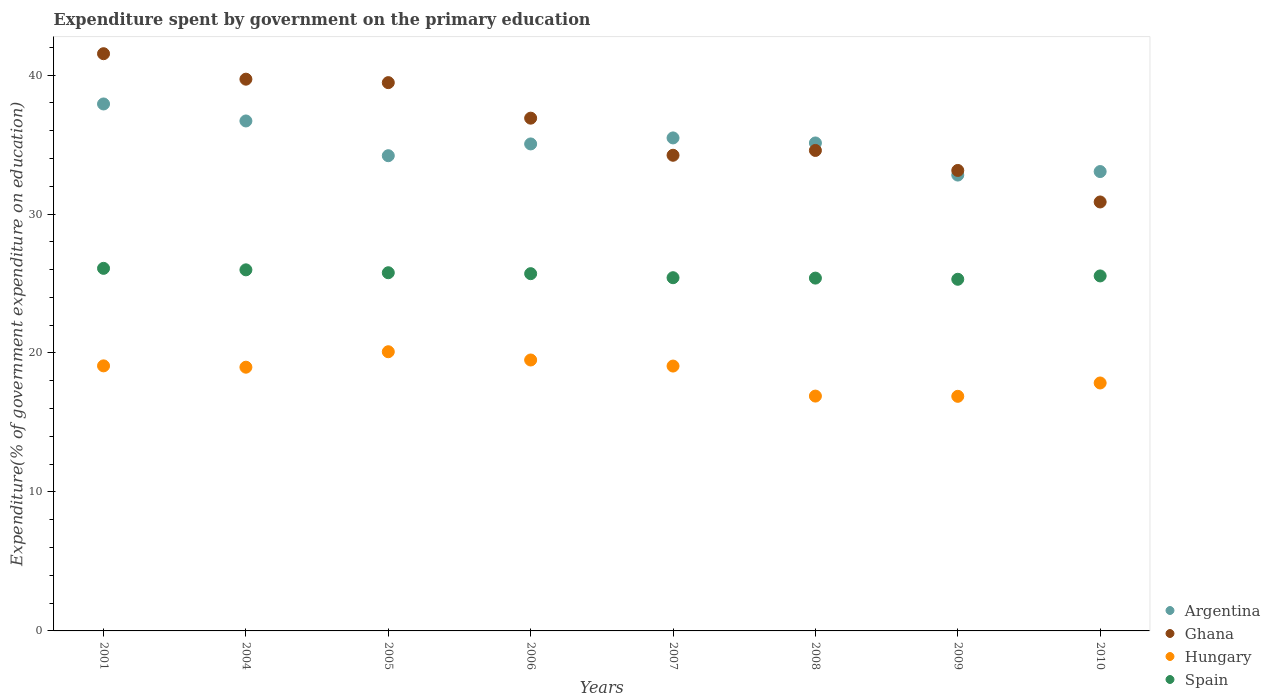How many different coloured dotlines are there?
Provide a short and direct response. 4. What is the expenditure spent by government on the primary education in Argentina in 2004?
Give a very brief answer. 36.7. Across all years, what is the maximum expenditure spent by government on the primary education in Hungary?
Give a very brief answer. 20.09. Across all years, what is the minimum expenditure spent by government on the primary education in Hungary?
Ensure brevity in your answer.  16.88. In which year was the expenditure spent by government on the primary education in Hungary maximum?
Ensure brevity in your answer.  2005. What is the total expenditure spent by government on the primary education in Hungary in the graph?
Give a very brief answer. 148.31. What is the difference between the expenditure spent by government on the primary education in Spain in 2004 and that in 2007?
Make the answer very short. 0.57. What is the difference between the expenditure spent by government on the primary education in Ghana in 2005 and the expenditure spent by government on the primary education in Hungary in 2010?
Make the answer very short. 21.61. What is the average expenditure spent by government on the primary education in Hungary per year?
Ensure brevity in your answer.  18.54. In the year 2005, what is the difference between the expenditure spent by government on the primary education in Hungary and expenditure spent by government on the primary education in Ghana?
Make the answer very short. -19.36. What is the ratio of the expenditure spent by government on the primary education in Hungary in 2001 to that in 2007?
Your answer should be very brief. 1. Is the difference between the expenditure spent by government on the primary education in Hungary in 2005 and 2007 greater than the difference between the expenditure spent by government on the primary education in Ghana in 2005 and 2007?
Your response must be concise. No. What is the difference between the highest and the second highest expenditure spent by government on the primary education in Ghana?
Your response must be concise. 1.83. What is the difference between the highest and the lowest expenditure spent by government on the primary education in Argentina?
Provide a succinct answer. 5.12. In how many years, is the expenditure spent by government on the primary education in Ghana greater than the average expenditure spent by government on the primary education in Ghana taken over all years?
Offer a very short reply. 4. Is the sum of the expenditure spent by government on the primary education in Argentina in 2004 and 2009 greater than the maximum expenditure spent by government on the primary education in Hungary across all years?
Your answer should be very brief. Yes. Is it the case that in every year, the sum of the expenditure spent by government on the primary education in Ghana and expenditure spent by government on the primary education in Spain  is greater than the expenditure spent by government on the primary education in Argentina?
Make the answer very short. Yes. Is the expenditure spent by government on the primary education in Ghana strictly greater than the expenditure spent by government on the primary education in Spain over the years?
Ensure brevity in your answer.  Yes. How many dotlines are there?
Offer a terse response. 4. How many years are there in the graph?
Give a very brief answer. 8. Does the graph contain any zero values?
Your answer should be compact. No. Where does the legend appear in the graph?
Make the answer very short. Bottom right. How many legend labels are there?
Offer a very short reply. 4. How are the legend labels stacked?
Your answer should be compact. Vertical. What is the title of the graph?
Ensure brevity in your answer.  Expenditure spent by government on the primary education. Does "Philippines" appear as one of the legend labels in the graph?
Give a very brief answer. No. What is the label or title of the Y-axis?
Provide a succinct answer. Expenditure(% of government expenditure on education). What is the Expenditure(% of government expenditure on education) of Argentina in 2001?
Ensure brevity in your answer.  37.92. What is the Expenditure(% of government expenditure on education) of Ghana in 2001?
Offer a very short reply. 41.54. What is the Expenditure(% of government expenditure on education) of Hungary in 2001?
Your answer should be compact. 19.07. What is the Expenditure(% of government expenditure on education) of Spain in 2001?
Give a very brief answer. 26.09. What is the Expenditure(% of government expenditure on education) of Argentina in 2004?
Your answer should be compact. 36.7. What is the Expenditure(% of government expenditure on education) in Ghana in 2004?
Provide a short and direct response. 39.7. What is the Expenditure(% of government expenditure on education) in Hungary in 2004?
Your response must be concise. 18.98. What is the Expenditure(% of government expenditure on education) of Spain in 2004?
Your response must be concise. 25.98. What is the Expenditure(% of government expenditure on education) of Argentina in 2005?
Ensure brevity in your answer.  34.2. What is the Expenditure(% of government expenditure on education) of Ghana in 2005?
Your answer should be very brief. 39.45. What is the Expenditure(% of government expenditure on education) in Hungary in 2005?
Offer a very short reply. 20.09. What is the Expenditure(% of government expenditure on education) of Spain in 2005?
Give a very brief answer. 25.77. What is the Expenditure(% of government expenditure on education) of Argentina in 2006?
Offer a terse response. 35.04. What is the Expenditure(% of government expenditure on education) of Ghana in 2006?
Ensure brevity in your answer.  36.9. What is the Expenditure(% of government expenditure on education) of Hungary in 2006?
Give a very brief answer. 19.5. What is the Expenditure(% of government expenditure on education) of Spain in 2006?
Make the answer very short. 25.71. What is the Expenditure(% of government expenditure on education) of Argentina in 2007?
Give a very brief answer. 35.48. What is the Expenditure(% of government expenditure on education) of Ghana in 2007?
Your answer should be compact. 34.23. What is the Expenditure(% of government expenditure on education) in Hungary in 2007?
Your answer should be very brief. 19.06. What is the Expenditure(% of government expenditure on education) in Spain in 2007?
Provide a short and direct response. 25.42. What is the Expenditure(% of government expenditure on education) of Argentina in 2008?
Your answer should be compact. 35.11. What is the Expenditure(% of government expenditure on education) in Ghana in 2008?
Keep it short and to the point. 34.57. What is the Expenditure(% of government expenditure on education) in Hungary in 2008?
Ensure brevity in your answer.  16.9. What is the Expenditure(% of government expenditure on education) in Spain in 2008?
Keep it short and to the point. 25.39. What is the Expenditure(% of government expenditure on education) of Argentina in 2009?
Your answer should be compact. 32.8. What is the Expenditure(% of government expenditure on education) of Ghana in 2009?
Your answer should be very brief. 33.13. What is the Expenditure(% of government expenditure on education) of Hungary in 2009?
Offer a very short reply. 16.88. What is the Expenditure(% of government expenditure on education) of Spain in 2009?
Make the answer very short. 25.3. What is the Expenditure(% of government expenditure on education) in Argentina in 2010?
Give a very brief answer. 33.05. What is the Expenditure(% of government expenditure on education) of Ghana in 2010?
Your answer should be compact. 30.87. What is the Expenditure(% of government expenditure on education) of Hungary in 2010?
Offer a very short reply. 17.84. What is the Expenditure(% of government expenditure on education) in Spain in 2010?
Provide a succinct answer. 25.54. Across all years, what is the maximum Expenditure(% of government expenditure on education) of Argentina?
Offer a very short reply. 37.92. Across all years, what is the maximum Expenditure(% of government expenditure on education) in Ghana?
Your answer should be compact. 41.54. Across all years, what is the maximum Expenditure(% of government expenditure on education) of Hungary?
Keep it short and to the point. 20.09. Across all years, what is the maximum Expenditure(% of government expenditure on education) of Spain?
Offer a very short reply. 26.09. Across all years, what is the minimum Expenditure(% of government expenditure on education) of Argentina?
Ensure brevity in your answer.  32.8. Across all years, what is the minimum Expenditure(% of government expenditure on education) of Ghana?
Make the answer very short. 30.87. Across all years, what is the minimum Expenditure(% of government expenditure on education) of Hungary?
Make the answer very short. 16.88. Across all years, what is the minimum Expenditure(% of government expenditure on education) of Spain?
Provide a short and direct response. 25.3. What is the total Expenditure(% of government expenditure on education) of Argentina in the graph?
Your answer should be compact. 280.3. What is the total Expenditure(% of government expenditure on education) of Ghana in the graph?
Provide a short and direct response. 290.39. What is the total Expenditure(% of government expenditure on education) of Hungary in the graph?
Offer a very short reply. 148.31. What is the total Expenditure(% of government expenditure on education) of Spain in the graph?
Your answer should be compact. 205.21. What is the difference between the Expenditure(% of government expenditure on education) in Argentina in 2001 and that in 2004?
Offer a very short reply. 1.22. What is the difference between the Expenditure(% of government expenditure on education) in Ghana in 2001 and that in 2004?
Provide a succinct answer. 1.83. What is the difference between the Expenditure(% of government expenditure on education) in Hungary in 2001 and that in 2004?
Give a very brief answer. 0.1. What is the difference between the Expenditure(% of government expenditure on education) of Spain in 2001 and that in 2004?
Provide a short and direct response. 0.11. What is the difference between the Expenditure(% of government expenditure on education) in Argentina in 2001 and that in 2005?
Your answer should be very brief. 3.72. What is the difference between the Expenditure(% of government expenditure on education) in Ghana in 2001 and that in 2005?
Your answer should be compact. 2.08. What is the difference between the Expenditure(% of government expenditure on education) of Hungary in 2001 and that in 2005?
Provide a succinct answer. -1.02. What is the difference between the Expenditure(% of government expenditure on education) of Spain in 2001 and that in 2005?
Your answer should be compact. 0.32. What is the difference between the Expenditure(% of government expenditure on education) of Argentina in 2001 and that in 2006?
Offer a terse response. 2.88. What is the difference between the Expenditure(% of government expenditure on education) in Ghana in 2001 and that in 2006?
Provide a short and direct response. 4.64. What is the difference between the Expenditure(% of government expenditure on education) of Hungary in 2001 and that in 2006?
Offer a terse response. -0.42. What is the difference between the Expenditure(% of government expenditure on education) in Spain in 2001 and that in 2006?
Provide a short and direct response. 0.38. What is the difference between the Expenditure(% of government expenditure on education) in Argentina in 2001 and that in 2007?
Your answer should be very brief. 2.44. What is the difference between the Expenditure(% of government expenditure on education) of Ghana in 2001 and that in 2007?
Keep it short and to the point. 7.31. What is the difference between the Expenditure(% of government expenditure on education) in Hungary in 2001 and that in 2007?
Your response must be concise. 0.01. What is the difference between the Expenditure(% of government expenditure on education) of Spain in 2001 and that in 2007?
Your answer should be very brief. 0.67. What is the difference between the Expenditure(% of government expenditure on education) of Argentina in 2001 and that in 2008?
Offer a terse response. 2.81. What is the difference between the Expenditure(% of government expenditure on education) of Ghana in 2001 and that in 2008?
Your answer should be very brief. 6.96. What is the difference between the Expenditure(% of government expenditure on education) in Hungary in 2001 and that in 2008?
Your answer should be compact. 2.17. What is the difference between the Expenditure(% of government expenditure on education) in Spain in 2001 and that in 2008?
Offer a very short reply. 0.7. What is the difference between the Expenditure(% of government expenditure on education) of Argentina in 2001 and that in 2009?
Ensure brevity in your answer.  5.12. What is the difference between the Expenditure(% of government expenditure on education) of Ghana in 2001 and that in 2009?
Keep it short and to the point. 8.4. What is the difference between the Expenditure(% of government expenditure on education) of Hungary in 2001 and that in 2009?
Provide a succinct answer. 2.19. What is the difference between the Expenditure(% of government expenditure on education) in Spain in 2001 and that in 2009?
Make the answer very short. 0.79. What is the difference between the Expenditure(% of government expenditure on education) in Argentina in 2001 and that in 2010?
Your answer should be very brief. 4.86. What is the difference between the Expenditure(% of government expenditure on education) of Ghana in 2001 and that in 2010?
Your answer should be very brief. 10.67. What is the difference between the Expenditure(% of government expenditure on education) of Hungary in 2001 and that in 2010?
Your response must be concise. 1.23. What is the difference between the Expenditure(% of government expenditure on education) of Spain in 2001 and that in 2010?
Your response must be concise. 0.55. What is the difference between the Expenditure(% of government expenditure on education) in Argentina in 2004 and that in 2005?
Keep it short and to the point. 2.5. What is the difference between the Expenditure(% of government expenditure on education) in Ghana in 2004 and that in 2005?
Make the answer very short. 0.25. What is the difference between the Expenditure(% of government expenditure on education) in Hungary in 2004 and that in 2005?
Your response must be concise. -1.11. What is the difference between the Expenditure(% of government expenditure on education) in Spain in 2004 and that in 2005?
Provide a succinct answer. 0.21. What is the difference between the Expenditure(% of government expenditure on education) of Argentina in 2004 and that in 2006?
Offer a very short reply. 1.65. What is the difference between the Expenditure(% of government expenditure on education) in Ghana in 2004 and that in 2006?
Make the answer very short. 2.81. What is the difference between the Expenditure(% of government expenditure on education) in Hungary in 2004 and that in 2006?
Your response must be concise. -0.52. What is the difference between the Expenditure(% of government expenditure on education) of Spain in 2004 and that in 2006?
Your answer should be very brief. 0.28. What is the difference between the Expenditure(% of government expenditure on education) in Argentina in 2004 and that in 2007?
Your answer should be compact. 1.22. What is the difference between the Expenditure(% of government expenditure on education) of Ghana in 2004 and that in 2007?
Provide a succinct answer. 5.47. What is the difference between the Expenditure(% of government expenditure on education) in Hungary in 2004 and that in 2007?
Your answer should be compact. -0.08. What is the difference between the Expenditure(% of government expenditure on education) in Spain in 2004 and that in 2007?
Ensure brevity in your answer.  0.57. What is the difference between the Expenditure(% of government expenditure on education) of Argentina in 2004 and that in 2008?
Provide a short and direct response. 1.58. What is the difference between the Expenditure(% of government expenditure on education) in Ghana in 2004 and that in 2008?
Your answer should be compact. 5.13. What is the difference between the Expenditure(% of government expenditure on education) in Hungary in 2004 and that in 2008?
Provide a short and direct response. 2.08. What is the difference between the Expenditure(% of government expenditure on education) in Spain in 2004 and that in 2008?
Your answer should be very brief. 0.59. What is the difference between the Expenditure(% of government expenditure on education) in Argentina in 2004 and that in 2009?
Your answer should be compact. 3.89. What is the difference between the Expenditure(% of government expenditure on education) of Ghana in 2004 and that in 2009?
Give a very brief answer. 6.57. What is the difference between the Expenditure(% of government expenditure on education) of Hungary in 2004 and that in 2009?
Your answer should be very brief. 2.1. What is the difference between the Expenditure(% of government expenditure on education) in Spain in 2004 and that in 2009?
Your response must be concise. 0.68. What is the difference between the Expenditure(% of government expenditure on education) of Argentina in 2004 and that in 2010?
Your response must be concise. 3.64. What is the difference between the Expenditure(% of government expenditure on education) of Ghana in 2004 and that in 2010?
Give a very brief answer. 8.84. What is the difference between the Expenditure(% of government expenditure on education) of Hungary in 2004 and that in 2010?
Offer a terse response. 1.14. What is the difference between the Expenditure(% of government expenditure on education) of Spain in 2004 and that in 2010?
Provide a succinct answer. 0.44. What is the difference between the Expenditure(% of government expenditure on education) in Argentina in 2005 and that in 2006?
Your response must be concise. -0.85. What is the difference between the Expenditure(% of government expenditure on education) in Ghana in 2005 and that in 2006?
Make the answer very short. 2.56. What is the difference between the Expenditure(% of government expenditure on education) in Hungary in 2005 and that in 2006?
Provide a short and direct response. 0.59. What is the difference between the Expenditure(% of government expenditure on education) of Spain in 2005 and that in 2006?
Provide a short and direct response. 0.07. What is the difference between the Expenditure(% of government expenditure on education) in Argentina in 2005 and that in 2007?
Offer a terse response. -1.28. What is the difference between the Expenditure(% of government expenditure on education) of Ghana in 2005 and that in 2007?
Your answer should be very brief. 5.23. What is the difference between the Expenditure(% of government expenditure on education) in Hungary in 2005 and that in 2007?
Offer a very short reply. 1.03. What is the difference between the Expenditure(% of government expenditure on education) of Spain in 2005 and that in 2007?
Provide a succinct answer. 0.36. What is the difference between the Expenditure(% of government expenditure on education) in Argentina in 2005 and that in 2008?
Make the answer very short. -0.92. What is the difference between the Expenditure(% of government expenditure on education) of Ghana in 2005 and that in 2008?
Offer a terse response. 4.88. What is the difference between the Expenditure(% of government expenditure on education) of Hungary in 2005 and that in 2008?
Give a very brief answer. 3.19. What is the difference between the Expenditure(% of government expenditure on education) of Spain in 2005 and that in 2008?
Your answer should be compact. 0.39. What is the difference between the Expenditure(% of government expenditure on education) in Argentina in 2005 and that in 2009?
Keep it short and to the point. 1.39. What is the difference between the Expenditure(% of government expenditure on education) in Ghana in 2005 and that in 2009?
Offer a very short reply. 6.32. What is the difference between the Expenditure(% of government expenditure on education) in Hungary in 2005 and that in 2009?
Offer a terse response. 3.21. What is the difference between the Expenditure(% of government expenditure on education) in Spain in 2005 and that in 2009?
Make the answer very short. 0.47. What is the difference between the Expenditure(% of government expenditure on education) of Argentina in 2005 and that in 2010?
Your answer should be compact. 1.14. What is the difference between the Expenditure(% of government expenditure on education) of Ghana in 2005 and that in 2010?
Offer a very short reply. 8.59. What is the difference between the Expenditure(% of government expenditure on education) in Hungary in 2005 and that in 2010?
Provide a succinct answer. 2.25. What is the difference between the Expenditure(% of government expenditure on education) of Spain in 2005 and that in 2010?
Provide a short and direct response. 0.23. What is the difference between the Expenditure(% of government expenditure on education) in Argentina in 2006 and that in 2007?
Offer a terse response. -0.43. What is the difference between the Expenditure(% of government expenditure on education) in Ghana in 2006 and that in 2007?
Your response must be concise. 2.67. What is the difference between the Expenditure(% of government expenditure on education) of Hungary in 2006 and that in 2007?
Give a very brief answer. 0.44. What is the difference between the Expenditure(% of government expenditure on education) in Spain in 2006 and that in 2007?
Provide a short and direct response. 0.29. What is the difference between the Expenditure(% of government expenditure on education) in Argentina in 2006 and that in 2008?
Your answer should be compact. -0.07. What is the difference between the Expenditure(% of government expenditure on education) of Ghana in 2006 and that in 2008?
Give a very brief answer. 2.32. What is the difference between the Expenditure(% of government expenditure on education) in Hungary in 2006 and that in 2008?
Your answer should be compact. 2.6. What is the difference between the Expenditure(% of government expenditure on education) of Spain in 2006 and that in 2008?
Offer a terse response. 0.32. What is the difference between the Expenditure(% of government expenditure on education) of Argentina in 2006 and that in 2009?
Your answer should be compact. 2.24. What is the difference between the Expenditure(% of government expenditure on education) of Ghana in 2006 and that in 2009?
Provide a succinct answer. 3.76. What is the difference between the Expenditure(% of government expenditure on education) of Hungary in 2006 and that in 2009?
Your answer should be very brief. 2.61. What is the difference between the Expenditure(% of government expenditure on education) in Spain in 2006 and that in 2009?
Offer a terse response. 0.4. What is the difference between the Expenditure(% of government expenditure on education) of Argentina in 2006 and that in 2010?
Make the answer very short. 1.99. What is the difference between the Expenditure(% of government expenditure on education) in Ghana in 2006 and that in 2010?
Your response must be concise. 6.03. What is the difference between the Expenditure(% of government expenditure on education) in Hungary in 2006 and that in 2010?
Your answer should be very brief. 1.65. What is the difference between the Expenditure(% of government expenditure on education) in Spain in 2006 and that in 2010?
Give a very brief answer. 0.16. What is the difference between the Expenditure(% of government expenditure on education) in Argentina in 2007 and that in 2008?
Provide a succinct answer. 0.36. What is the difference between the Expenditure(% of government expenditure on education) in Ghana in 2007 and that in 2008?
Offer a very short reply. -0.35. What is the difference between the Expenditure(% of government expenditure on education) in Hungary in 2007 and that in 2008?
Offer a terse response. 2.16. What is the difference between the Expenditure(% of government expenditure on education) in Spain in 2007 and that in 2008?
Your answer should be compact. 0.03. What is the difference between the Expenditure(% of government expenditure on education) of Argentina in 2007 and that in 2009?
Give a very brief answer. 2.67. What is the difference between the Expenditure(% of government expenditure on education) in Ghana in 2007 and that in 2009?
Your answer should be very brief. 1.09. What is the difference between the Expenditure(% of government expenditure on education) of Hungary in 2007 and that in 2009?
Provide a succinct answer. 2.18. What is the difference between the Expenditure(% of government expenditure on education) in Spain in 2007 and that in 2009?
Your response must be concise. 0.11. What is the difference between the Expenditure(% of government expenditure on education) in Argentina in 2007 and that in 2010?
Make the answer very short. 2.42. What is the difference between the Expenditure(% of government expenditure on education) of Ghana in 2007 and that in 2010?
Keep it short and to the point. 3.36. What is the difference between the Expenditure(% of government expenditure on education) in Hungary in 2007 and that in 2010?
Ensure brevity in your answer.  1.22. What is the difference between the Expenditure(% of government expenditure on education) in Spain in 2007 and that in 2010?
Give a very brief answer. -0.13. What is the difference between the Expenditure(% of government expenditure on education) of Argentina in 2008 and that in 2009?
Keep it short and to the point. 2.31. What is the difference between the Expenditure(% of government expenditure on education) of Ghana in 2008 and that in 2009?
Keep it short and to the point. 1.44. What is the difference between the Expenditure(% of government expenditure on education) in Hungary in 2008 and that in 2009?
Offer a very short reply. 0.02. What is the difference between the Expenditure(% of government expenditure on education) of Spain in 2008 and that in 2009?
Your response must be concise. 0.08. What is the difference between the Expenditure(% of government expenditure on education) in Argentina in 2008 and that in 2010?
Make the answer very short. 2.06. What is the difference between the Expenditure(% of government expenditure on education) in Ghana in 2008 and that in 2010?
Your answer should be very brief. 3.71. What is the difference between the Expenditure(% of government expenditure on education) in Hungary in 2008 and that in 2010?
Provide a succinct answer. -0.94. What is the difference between the Expenditure(% of government expenditure on education) of Spain in 2008 and that in 2010?
Offer a very short reply. -0.16. What is the difference between the Expenditure(% of government expenditure on education) of Argentina in 2009 and that in 2010?
Provide a succinct answer. -0.25. What is the difference between the Expenditure(% of government expenditure on education) in Ghana in 2009 and that in 2010?
Your answer should be very brief. 2.27. What is the difference between the Expenditure(% of government expenditure on education) in Hungary in 2009 and that in 2010?
Your answer should be very brief. -0.96. What is the difference between the Expenditure(% of government expenditure on education) of Spain in 2009 and that in 2010?
Provide a succinct answer. -0.24. What is the difference between the Expenditure(% of government expenditure on education) of Argentina in 2001 and the Expenditure(% of government expenditure on education) of Ghana in 2004?
Make the answer very short. -1.78. What is the difference between the Expenditure(% of government expenditure on education) of Argentina in 2001 and the Expenditure(% of government expenditure on education) of Hungary in 2004?
Offer a very short reply. 18.94. What is the difference between the Expenditure(% of government expenditure on education) of Argentina in 2001 and the Expenditure(% of government expenditure on education) of Spain in 2004?
Keep it short and to the point. 11.94. What is the difference between the Expenditure(% of government expenditure on education) of Ghana in 2001 and the Expenditure(% of government expenditure on education) of Hungary in 2004?
Offer a very short reply. 22.56. What is the difference between the Expenditure(% of government expenditure on education) in Ghana in 2001 and the Expenditure(% of government expenditure on education) in Spain in 2004?
Offer a terse response. 15.55. What is the difference between the Expenditure(% of government expenditure on education) in Hungary in 2001 and the Expenditure(% of government expenditure on education) in Spain in 2004?
Ensure brevity in your answer.  -6.91. What is the difference between the Expenditure(% of government expenditure on education) in Argentina in 2001 and the Expenditure(% of government expenditure on education) in Ghana in 2005?
Ensure brevity in your answer.  -1.53. What is the difference between the Expenditure(% of government expenditure on education) in Argentina in 2001 and the Expenditure(% of government expenditure on education) in Hungary in 2005?
Provide a short and direct response. 17.83. What is the difference between the Expenditure(% of government expenditure on education) of Argentina in 2001 and the Expenditure(% of government expenditure on education) of Spain in 2005?
Provide a succinct answer. 12.14. What is the difference between the Expenditure(% of government expenditure on education) in Ghana in 2001 and the Expenditure(% of government expenditure on education) in Hungary in 2005?
Give a very brief answer. 21.45. What is the difference between the Expenditure(% of government expenditure on education) of Ghana in 2001 and the Expenditure(% of government expenditure on education) of Spain in 2005?
Your response must be concise. 15.76. What is the difference between the Expenditure(% of government expenditure on education) in Hungary in 2001 and the Expenditure(% of government expenditure on education) in Spain in 2005?
Provide a short and direct response. -6.7. What is the difference between the Expenditure(% of government expenditure on education) in Argentina in 2001 and the Expenditure(% of government expenditure on education) in Ghana in 2006?
Give a very brief answer. 1.02. What is the difference between the Expenditure(% of government expenditure on education) in Argentina in 2001 and the Expenditure(% of government expenditure on education) in Hungary in 2006?
Your answer should be very brief. 18.42. What is the difference between the Expenditure(% of government expenditure on education) of Argentina in 2001 and the Expenditure(% of government expenditure on education) of Spain in 2006?
Provide a succinct answer. 12.21. What is the difference between the Expenditure(% of government expenditure on education) of Ghana in 2001 and the Expenditure(% of government expenditure on education) of Hungary in 2006?
Your answer should be very brief. 22.04. What is the difference between the Expenditure(% of government expenditure on education) in Ghana in 2001 and the Expenditure(% of government expenditure on education) in Spain in 2006?
Your answer should be very brief. 15.83. What is the difference between the Expenditure(% of government expenditure on education) in Hungary in 2001 and the Expenditure(% of government expenditure on education) in Spain in 2006?
Give a very brief answer. -6.63. What is the difference between the Expenditure(% of government expenditure on education) in Argentina in 2001 and the Expenditure(% of government expenditure on education) in Ghana in 2007?
Provide a succinct answer. 3.69. What is the difference between the Expenditure(% of government expenditure on education) in Argentina in 2001 and the Expenditure(% of government expenditure on education) in Hungary in 2007?
Keep it short and to the point. 18.86. What is the difference between the Expenditure(% of government expenditure on education) in Argentina in 2001 and the Expenditure(% of government expenditure on education) in Spain in 2007?
Your answer should be very brief. 12.5. What is the difference between the Expenditure(% of government expenditure on education) in Ghana in 2001 and the Expenditure(% of government expenditure on education) in Hungary in 2007?
Offer a terse response. 22.48. What is the difference between the Expenditure(% of government expenditure on education) of Ghana in 2001 and the Expenditure(% of government expenditure on education) of Spain in 2007?
Your answer should be compact. 16.12. What is the difference between the Expenditure(% of government expenditure on education) in Hungary in 2001 and the Expenditure(% of government expenditure on education) in Spain in 2007?
Offer a terse response. -6.34. What is the difference between the Expenditure(% of government expenditure on education) of Argentina in 2001 and the Expenditure(% of government expenditure on education) of Ghana in 2008?
Your answer should be compact. 3.34. What is the difference between the Expenditure(% of government expenditure on education) of Argentina in 2001 and the Expenditure(% of government expenditure on education) of Hungary in 2008?
Make the answer very short. 21.02. What is the difference between the Expenditure(% of government expenditure on education) in Argentina in 2001 and the Expenditure(% of government expenditure on education) in Spain in 2008?
Make the answer very short. 12.53. What is the difference between the Expenditure(% of government expenditure on education) of Ghana in 2001 and the Expenditure(% of government expenditure on education) of Hungary in 2008?
Ensure brevity in your answer.  24.64. What is the difference between the Expenditure(% of government expenditure on education) of Ghana in 2001 and the Expenditure(% of government expenditure on education) of Spain in 2008?
Your answer should be very brief. 16.15. What is the difference between the Expenditure(% of government expenditure on education) in Hungary in 2001 and the Expenditure(% of government expenditure on education) in Spain in 2008?
Make the answer very short. -6.32. What is the difference between the Expenditure(% of government expenditure on education) in Argentina in 2001 and the Expenditure(% of government expenditure on education) in Ghana in 2009?
Your answer should be very brief. 4.78. What is the difference between the Expenditure(% of government expenditure on education) in Argentina in 2001 and the Expenditure(% of government expenditure on education) in Hungary in 2009?
Keep it short and to the point. 21.04. What is the difference between the Expenditure(% of government expenditure on education) of Argentina in 2001 and the Expenditure(% of government expenditure on education) of Spain in 2009?
Your response must be concise. 12.61. What is the difference between the Expenditure(% of government expenditure on education) in Ghana in 2001 and the Expenditure(% of government expenditure on education) in Hungary in 2009?
Ensure brevity in your answer.  24.65. What is the difference between the Expenditure(% of government expenditure on education) in Ghana in 2001 and the Expenditure(% of government expenditure on education) in Spain in 2009?
Offer a terse response. 16.23. What is the difference between the Expenditure(% of government expenditure on education) of Hungary in 2001 and the Expenditure(% of government expenditure on education) of Spain in 2009?
Provide a short and direct response. -6.23. What is the difference between the Expenditure(% of government expenditure on education) in Argentina in 2001 and the Expenditure(% of government expenditure on education) in Ghana in 2010?
Offer a very short reply. 7.05. What is the difference between the Expenditure(% of government expenditure on education) of Argentina in 2001 and the Expenditure(% of government expenditure on education) of Hungary in 2010?
Make the answer very short. 20.08. What is the difference between the Expenditure(% of government expenditure on education) of Argentina in 2001 and the Expenditure(% of government expenditure on education) of Spain in 2010?
Provide a short and direct response. 12.37. What is the difference between the Expenditure(% of government expenditure on education) of Ghana in 2001 and the Expenditure(% of government expenditure on education) of Hungary in 2010?
Give a very brief answer. 23.69. What is the difference between the Expenditure(% of government expenditure on education) in Ghana in 2001 and the Expenditure(% of government expenditure on education) in Spain in 2010?
Keep it short and to the point. 15.99. What is the difference between the Expenditure(% of government expenditure on education) in Hungary in 2001 and the Expenditure(% of government expenditure on education) in Spain in 2010?
Ensure brevity in your answer.  -6.47. What is the difference between the Expenditure(% of government expenditure on education) in Argentina in 2004 and the Expenditure(% of government expenditure on education) in Ghana in 2005?
Your response must be concise. -2.76. What is the difference between the Expenditure(% of government expenditure on education) of Argentina in 2004 and the Expenditure(% of government expenditure on education) of Hungary in 2005?
Provide a succinct answer. 16.61. What is the difference between the Expenditure(% of government expenditure on education) of Argentina in 2004 and the Expenditure(% of government expenditure on education) of Spain in 2005?
Your answer should be compact. 10.92. What is the difference between the Expenditure(% of government expenditure on education) in Ghana in 2004 and the Expenditure(% of government expenditure on education) in Hungary in 2005?
Provide a short and direct response. 19.61. What is the difference between the Expenditure(% of government expenditure on education) in Ghana in 2004 and the Expenditure(% of government expenditure on education) in Spain in 2005?
Give a very brief answer. 13.93. What is the difference between the Expenditure(% of government expenditure on education) in Hungary in 2004 and the Expenditure(% of government expenditure on education) in Spain in 2005?
Provide a succinct answer. -6.8. What is the difference between the Expenditure(% of government expenditure on education) in Argentina in 2004 and the Expenditure(% of government expenditure on education) in Ghana in 2006?
Your answer should be very brief. -0.2. What is the difference between the Expenditure(% of government expenditure on education) of Argentina in 2004 and the Expenditure(% of government expenditure on education) of Hungary in 2006?
Keep it short and to the point. 17.2. What is the difference between the Expenditure(% of government expenditure on education) of Argentina in 2004 and the Expenditure(% of government expenditure on education) of Spain in 2006?
Your response must be concise. 10.99. What is the difference between the Expenditure(% of government expenditure on education) in Ghana in 2004 and the Expenditure(% of government expenditure on education) in Hungary in 2006?
Your answer should be very brief. 20.21. What is the difference between the Expenditure(% of government expenditure on education) in Ghana in 2004 and the Expenditure(% of government expenditure on education) in Spain in 2006?
Make the answer very short. 14. What is the difference between the Expenditure(% of government expenditure on education) in Hungary in 2004 and the Expenditure(% of government expenditure on education) in Spain in 2006?
Keep it short and to the point. -6.73. What is the difference between the Expenditure(% of government expenditure on education) of Argentina in 2004 and the Expenditure(% of government expenditure on education) of Ghana in 2007?
Keep it short and to the point. 2.47. What is the difference between the Expenditure(% of government expenditure on education) in Argentina in 2004 and the Expenditure(% of government expenditure on education) in Hungary in 2007?
Ensure brevity in your answer.  17.64. What is the difference between the Expenditure(% of government expenditure on education) of Argentina in 2004 and the Expenditure(% of government expenditure on education) of Spain in 2007?
Ensure brevity in your answer.  11.28. What is the difference between the Expenditure(% of government expenditure on education) in Ghana in 2004 and the Expenditure(% of government expenditure on education) in Hungary in 2007?
Your answer should be compact. 20.64. What is the difference between the Expenditure(% of government expenditure on education) in Ghana in 2004 and the Expenditure(% of government expenditure on education) in Spain in 2007?
Offer a terse response. 14.29. What is the difference between the Expenditure(% of government expenditure on education) in Hungary in 2004 and the Expenditure(% of government expenditure on education) in Spain in 2007?
Provide a succinct answer. -6.44. What is the difference between the Expenditure(% of government expenditure on education) in Argentina in 2004 and the Expenditure(% of government expenditure on education) in Ghana in 2008?
Your response must be concise. 2.12. What is the difference between the Expenditure(% of government expenditure on education) of Argentina in 2004 and the Expenditure(% of government expenditure on education) of Hungary in 2008?
Provide a short and direct response. 19.8. What is the difference between the Expenditure(% of government expenditure on education) in Argentina in 2004 and the Expenditure(% of government expenditure on education) in Spain in 2008?
Keep it short and to the point. 11.31. What is the difference between the Expenditure(% of government expenditure on education) of Ghana in 2004 and the Expenditure(% of government expenditure on education) of Hungary in 2008?
Your answer should be very brief. 22.8. What is the difference between the Expenditure(% of government expenditure on education) of Ghana in 2004 and the Expenditure(% of government expenditure on education) of Spain in 2008?
Keep it short and to the point. 14.31. What is the difference between the Expenditure(% of government expenditure on education) in Hungary in 2004 and the Expenditure(% of government expenditure on education) in Spain in 2008?
Keep it short and to the point. -6.41. What is the difference between the Expenditure(% of government expenditure on education) of Argentina in 2004 and the Expenditure(% of government expenditure on education) of Ghana in 2009?
Provide a succinct answer. 3.56. What is the difference between the Expenditure(% of government expenditure on education) of Argentina in 2004 and the Expenditure(% of government expenditure on education) of Hungary in 2009?
Your answer should be compact. 19.81. What is the difference between the Expenditure(% of government expenditure on education) of Argentina in 2004 and the Expenditure(% of government expenditure on education) of Spain in 2009?
Your response must be concise. 11.39. What is the difference between the Expenditure(% of government expenditure on education) of Ghana in 2004 and the Expenditure(% of government expenditure on education) of Hungary in 2009?
Provide a short and direct response. 22.82. What is the difference between the Expenditure(% of government expenditure on education) of Ghana in 2004 and the Expenditure(% of government expenditure on education) of Spain in 2009?
Your answer should be compact. 14.4. What is the difference between the Expenditure(% of government expenditure on education) in Hungary in 2004 and the Expenditure(% of government expenditure on education) in Spain in 2009?
Your answer should be very brief. -6.33. What is the difference between the Expenditure(% of government expenditure on education) in Argentina in 2004 and the Expenditure(% of government expenditure on education) in Ghana in 2010?
Your answer should be very brief. 5.83. What is the difference between the Expenditure(% of government expenditure on education) in Argentina in 2004 and the Expenditure(% of government expenditure on education) in Hungary in 2010?
Ensure brevity in your answer.  18.85. What is the difference between the Expenditure(% of government expenditure on education) in Argentina in 2004 and the Expenditure(% of government expenditure on education) in Spain in 2010?
Your answer should be compact. 11.15. What is the difference between the Expenditure(% of government expenditure on education) of Ghana in 2004 and the Expenditure(% of government expenditure on education) of Hungary in 2010?
Give a very brief answer. 21.86. What is the difference between the Expenditure(% of government expenditure on education) in Ghana in 2004 and the Expenditure(% of government expenditure on education) in Spain in 2010?
Offer a very short reply. 14.16. What is the difference between the Expenditure(% of government expenditure on education) of Hungary in 2004 and the Expenditure(% of government expenditure on education) of Spain in 2010?
Your answer should be compact. -6.57. What is the difference between the Expenditure(% of government expenditure on education) in Argentina in 2005 and the Expenditure(% of government expenditure on education) in Ghana in 2006?
Your answer should be very brief. -2.7. What is the difference between the Expenditure(% of government expenditure on education) of Argentina in 2005 and the Expenditure(% of government expenditure on education) of Hungary in 2006?
Your response must be concise. 14.7. What is the difference between the Expenditure(% of government expenditure on education) of Argentina in 2005 and the Expenditure(% of government expenditure on education) of Spain in 2006?
Offer a very short reply. 8.49. What is the difference between the Expenditure(% of government expenditure on education) of Ghana in 2005 and the Expenditure(% of government expenditure on education) of Hungary in 2006?
Keep it short and to the point. 19.96. What is the difference between the Expenditure(% of government expenditure on education) in Ghana in 2005 and the Expenditure(% of government expenditure on education) in Spain in 2006?
Your answer should be very brief. 13.75. What is the difference between the Expenditure(% of government expenditure on education) of Hungary in 2005 and the Expenditure(% of government expenditure on education) of Spain in 2006?
Give a very brief answer. -5.62. What is the difference between the Expenditure(% of government expenditure on education) in Argentina in 2005 and the Expenditure(% of government expenditure on education) in Ghana in 2007?
Give a very brief answer. -0.03. What is the difference between the Expenditure(% of government expenditure on education) in Argentina in 2005 and the Expenditure(% of government expenditure on education) in Hungary in 2007?
Provide a short and direct response. 15.14. What is the difference between the Expenditure(% of government expenditure on education) in Argentina in 2005 and the Expenditure(% of government expenditure on education) in Spain in 2007?
Your response must be concise. 8.78. What is the difference between the Expenditure(% of government expenditure on education) in Ghana in 2005 and the Expenditure(% of government expenditure on education) in Hungary in 2007?
Give a very brief answer. 20.39. What is the difference between the Expenditure(% of government expenditure on education) of Ghana in 2005 and the Expenditure(% of government expenditure on education) of Spain in 2007?
Offer a very short reply. 14.04. What is the difference between the Expenditure(% of government expenditure on education) of Hungary in 2005 and the Expenditure(% of government expenditure on education) of Spain in 2007?
Give a very brief answer. -5.33. What is the difference between the Expenditure(% of government expenditure on education) of Argentina in 2005 and the Expenditure(% of government expenditure on education) of Ghana in 2008?
Your answer should be very brief. -0.38. What is the difference between the Expenditure(% of government expenditure on education) of Argentina in 2005 and the Expenditure(% of government expenditure on education) of Hungary in 2008?
Your answer should be compact. 17.3. What is the difference between the Expenditure(% of government expenditure on education) in Argentina in 2005 and the Expenditure(% of government expenditure on education) in Spain in 2008?
Offer a terse response. 8.81. What is the difference between the Expenditure(% of government expenditure on education) of Ghana in 2005 and the Expenditure(% of government expenditure on education) of Hungary in 2008?
Make the answer very short. 22.56. What is the difference between the Expenditure(% of government expenditure on education) in Ghana in 2005 and the Expenditure(% of government expenditure on education) in Spain in 2008?
Offer a terse response. 14.07. What is the difference between the Expenditure(% of government expenditure on education) of Hungary in 2005 and the Expenditure(% of government expenditure on education) of Spain in 2008?
Offer a very short reply. -5.3. What is the difference between the Expenditure(% of government expenditure on education) of Argentina in 2005 and the Expenditure(% of government expenditure on education) of Ghana in 2009?
Give a very brief answer. 1.06. What is the difference between the Expenditure(% of government expenditure on education) in Argentina in 2005 and the Expenditure(% of government expenditure on education) in Hungary in 2009?
Provide a short and direct response. 17.31. What is the difference between the Expenditure(% of government expenditure on education) in Argentina in 2005 and the Expenditure(% of government expenditure on education) in Spain in 2009?
Your response must be concise. 8.89. What is the difference between the Expenditure(% of government expenditure on education) of Ghana in 2005 and the Expenditure(% of government expenditure on education) of Hungary in 2009?
Offer a very short reply. 22.57. What is the difference between the Expenditure(% of government expenditure on education) of Ghana in 2005 and the Expenditure(% of government expenditure on education) of Spain in 2009?
Offer a terse response. 14.15. What is the difference between the Expenditure(% of government expenditure on education) in Hungary in 2005 and the Expenditure(% of government expenditure on education) in Spain in 2009?
Offer a terse response. -5.21. What is the difference between the Expenditure(% of government expenditure on education) in Argentina in 2005 and the Expenditure(% of government expenditure on education) in Ghana in 2010?
Your answer should be compact. 3.33. What is the difference between the Expenditure(% of government expenditure on education) in Argentina in 2005 and the Expenditure(% of government expenditure on education) in Hungary in 2010?
Provide a short and direct response. 16.35. What is the difference between the Expenditure(% of government expenditure on education) of Argentina in 2005 and the Expenditure(% of government expenditure on education) of Spain in 2010?
Your answer should be very brief. 8.65. What is the difference between the Expenditure(% of government expenditure on education) of Ghana in 2005 and the Expenditure(% of government expenditure on education) of Hungary in 2010?
Provide a short and direct response. 21.61. What is the difference between the Expenditure(% of government expenditure on education) of Ghana in 2005 and the Expenditure(% of government expenditure on education) of Spain in 2010?
Your answer should be compact. 13.91. What is the difference between the Expenditure(% of government expenditure on education) of Hungary in 2005 and the Expenditure(% of government expenditure on education) of Spain in 2010?
Make the answer very short. -5.46. What is the difference between the Expenditure(% of government expenditure on education) of Argentina in 2006 and the Expenditure(% of government expenditure on education) of Ghana in 2007?
Offer a terse response. 0.82. What is the difference between the Expenditure(% of government expenditure on education) of Argentina in 2006 and the Expenditure(% of government expenditure on education) of Hungary in 2007?
Give a very brief answer. 15.98. What is the difference between the Expenditure(% of government expenditure on education) in Argentina in 2006 and the Expenditure(% of government expenditure on education) in Spain in 2007?
Offer a very short reply. 9.63. What is the difference between the Expenditure(% of government expenditure on education) in Ghana in 2006 and the Expenditure(% of government expenditure on education) in Hungary in 2007?
Your answer should be very brief. 17.84. What is the difference between the Expenditure(% of government expenditure on education) in Ghana in 2006 and the Expenditure(% of government expenditure on education) in Spain in 2007?
Your answer should be compact. 11.48. What is the difference between the Expenditure(% of government expenditure on education) of Hungary in 2006 and the Expenditure(% of government expenditure on education) of Spain in 2007?
Make the answer very short. -5.92. What is the difference between the Expenditure(% of government expenditure on education) of Argentina in 2006 and the Expenditure(% of government expenditure on education) of Ghana in 2008?
Give a very brief answer. 0.47. What is the difference between the Expenditure(% of government expenditure on education) of Argentina in 2006 and the Expenditure(% of government expenditure on education) of Hungary in 2008?
Give a very brief answer. 18.14. What is the difference between the Expenditure(% of government expenditure on education) of Argentina in 2006 and the Expenditure(% of government expenditure on education) of Spain in 2008?
Ensure brevity in your answer.  9.65. What is the difference between the Expenditure(% of government expenditure on education) in Ghana in 2006 and the Expenditure(% of government expenditure on education) in Hungary in 2008?
Your response must be concise. 20. What is the difference between the Expenditure(% of government expenditure on education) of Ghana in 2006 and the Expenditure(% of government expenditure on education) of Spain in 2008?
Offer a very short reply. 11.51. What is the difference between the Expenditure(% of government expenditure on education) of Hungary in 2006 and the Expenditure(% of government expenditure on education) of Spain in 2008?
Provide a short and direct response. -5.89. What is the difference between the Expenditure(% of government expenditure on education) of Argentina in 2006 and the Expenditure(% of government expenditure on education) of Ghana in 2009?
Ensure brevity in your answer.  1.91. What is the difference between the Expenditure(% of government expenditure on education) of Argentina in 2006 and the Expenditure(% of government expenditure on education) of Hungary in 2009?
Ensure brevity in your answer.  18.16. What is the difference between the Expenditure(% of government expenditure on education) in Argentina in 2006 and the Expenditure(% of government expenditure on education) in Spain in 2009?
Your answer should be very brief. 9.74. What is the difference between the Expenditure(% of government expenditure on education) in Ghana in 2006 and the Expenditure(% of government expenditure on education) in Hungary in 2009?
Offer a terse response. 20.02. What is the difference between the Expenditure(% of government expenditure on education) in Ghana in 2006 and the Expenditure(% of government expenditure on education) in Spain in 2009?
Provide a succinct answer. 11.59. What is the difference between the Expenditure(% of government expenditure on education) in Hungary in 2006 and the Expenditure(% of government expenditure on education) in Spain in 2009?
Offer a very short reply. -5.81. What is the difference between the Expenditure(% of government expenditure on education) of Argentina in 2006 and the Expenditure(% of government expenditure on education) of Ghana in 2010?
Ensure brevity in your answer.  4.18. What is the difference between the Expenditure(% of government expenditure on education) in Argentina in 2006 and the Expenditure(% of government expenditure on education) in Hungary in 2010?
Provide a succinct answer. 17.2. What is the difference between the Expenditure(% of government expenditure on education) in Argentina in 2006 and the Expenditure(% of government expenditure on education) in Spain in 2010?
Your answer should be very brief. 9.5. What is the difference between the Expenditure(% of government expenditure on education) of Ghana in 2006 and the Expenditure(% of government expenditure on education) of Hungary in 2010?
Offer a terse response. 19.06. What is the difference between the Expenditure(% of government expenditure on education) in Ghana in 2006 and the Expenditure(% of government expenditure on education) in Spain in 2010?
Give a very brief answer. 11.35. What is the difference between the Expenditure(% of government expenditure on education) of Hungary in 2006 and the Expenditure(% of government expenditure on education) of Spain in 2010?
Your response must be concise. -6.05. What is the difference between the Expenditure(% of government expenditure on education) of Argentina in 2007 and the Expenditure(% of government expenditure on education) of Ghana in 2008?
Your answer should be very brief. 0.9. What is the difference between the Expenditure(% of government expenditure on education) in Argentina in 2007 and the Expenditure(% of government expenditure on education) in Hungary in 2008?
Ensure brevity in your answer.  18.58. What is the difference between the Expenditure(% of government expenditure on education) in Argentina in 2007 and the Expenditure(% of government expenditure on education) in Spain in 2008?
Provide a succinct answer. 10.09. What is the difference between the Expenditure(% of government expenditure on education) in Ghana in 2007 and the Expenditure(% of government expenditure on education) in Hungary in 2008?
Your answer should be very brief. 17.33. What is the difference between the Expenditure(% of government expenditure on education) of Ghana in 2007 and the Expenditure(% of government expenditure on education) of Spain in 2008?
Give a very brief answer. 8.84. What is the difference between the Expenditure(% of government expenditure on education) of Hungary in 2007 and the Expenditure(% of government expenditure on education) of Spain in 2008?
Provide a short and direct response. -6.33. What is the difference between the Expenditure(% of government expenditure on education) of Argentina in 2007 and the Expenditure(% of government expenditure on education) of Ghana in 2009?
Ensure brevity in your answer.  2.34. What is the difference between the Expenditure(% of government expenditure on education) of Argentina in 2007 and the Expenditure(% of government expenditure on education) of Hungary in 2009?
Make the answer very short. 18.59. What is the difference between the Expenditure(% of government expenditure on education) of Argentina in 2007 and the Expenditure(% of government expenditure on education) of Spain in 2009?
Your answer should be very brief. 10.17. What is the difference between the Expenditure(% of government expenditure on education) of Ghana in 2007 and the Expenditure(% of government expenditure on education) of Hungary in 2009?
Offer a very short reply. 17.35. What is the difference between the Expenditure(% of government expenditure on education) in Ghana in 2007 and the Expenditure(% of government expenditure on education) in Spain in 2009?
Your answer should be very brief. 8.92. What is the difference between the Expenditure(% of government expenditure on education) in Hungary in 2007 and the Expenditure(% of government expenditure on education) in Spain in 2009?
Your answer should be compact. -6.25. What is the difference between the Expenditure(% of government expenditure on education) in Argentina in 2007 and the Expenditure(% of government expenditure on education) in Ghana in 2010?
Ensure brevity in your answer.  4.61. What is the difference between the Expenditure(% of government expenditure on education) in Argentina in 2007 and the Expenditure(% of government expenditure on education) in Hungary in 2010?
Your answer should be very brief. 17.63. What is the difference between the Expenditure(% of government expenditure on education) in Argentina in 2007 and the Expenditure(% of government expenditure on education) in Spain in 2010?
Provide a succinct answer. 9.93. What is the difference between the Expenditure(% of government expenditure on education) in Ghana in 2007 and the Expenditure(% of government expenditure on education) in Hungary in 2010?
Provide a short and direct response. 16.39. What is the difference between the Expenditure(% of government expenditure on education) of Ghana in 2007 and the Expenditure(% of government expenditure on education) of Spain in 2010?
Provide a short and direct response. 8.68. What is the difference between the Expenditure(% of government expenditure on education) of Hungary in 2007 and the Expenditure(% of government expenditure on education) of Spain in 2010?
Your answer should be very brief. -6.49. What is the difference between the Expenditure(% of government expenditure on education) of Argentina in 2008 and the Expenditure(% of government expenditure on education) of Ghana in 2009?
Your answer should be very brief. 1.98. What is the difference between the Expenditure(% of government expenditure on education) of Argentina in 2008 and the Expenditure(% of government expenditure on education) of Hungary in 2009?
Offer a very short reply. 18.23. What is the difference between the Expenditure(% of government expenditure on education) of Argentina in 2008 and the Expenditure(% of government expenditure on education) of Spain in 2009?
Provide a short and direct response. 9.81. What is the difference between the Expenditure(% of government expenditure on education) of Ghana in 2008 and the Expenditure(% of government expenditure on education) of Hungary in 2009?
Give a very brief answer. 17.69. What is the difference between the Expenditure(% of government expenditure on education) of Ghana in 2008 and the Expenditure(% of government expenditure on education) of Spain in 2009?
Keep it short and to the point. 9.27. What is the difference between the Expenditure(% of government expenditure on education) in Hungary in 2008 and the Expenditure(% of government expenditure on education) in Spain in 2009?
Give a very brief answer. -8.41. What is the difference between the Expenditure(% of government expenditure on education) in Argentina in 2008 and the Expenditure(% of government expenditure on education) in Ghana in 2010?
Your answer should be very brief. 4.25. What is the difference between the Expenditure(% of government expenditure on education) in Argentina in 2008 and the Expenditure(% of government expenditure on education) in Hungary in 2010?
Give a very brief answer. 17.27. What is the difference between the Expenditure(% of government expenditure on education) of Argentina in 2008 and the Expenditure(% of government expenditure on education) of Spain in 2010?
Offer a terse response. 9.57. What is the difference between the Expenditure(% of government expenditure on education) of Ghana in 2008 and the Expenditure(% of government expenditure on education) of Hungary in 2010?
Ensure brevity in your answer.  16.73. What is the difference between the Expenditure(% of government expenditure on education) of Ghana in 2008 and the Expenditure(% of government expenditure on education) of Spain in 2010?
Provide a succinct answer. 9.03. What is the difference between the Expenditure(% of government expenditure on education) in Hungary in 2008 and the Expenditure(% of government expenditure on education) in Spain in 2010?
Ensure brevity in your answer.  -8.65. What is the difference between the Expenditure(% of government expenditure on education) in Argentina in 2009 and the Expenditure(% of government expenditure on education) in Ghana in 2010?
Provide a short and direct response. 1.94. What is the difference between the Expenditure(% of government expenditure on education) of Argentina in 2009 and the Expenditure(% of government expenditure on education) of Hungary in 2010?
Your answer should be compact. 14.96. What is the difference between the Expenditure(% of government expenditure on education) of Argentina in 2009 and the Expenditure(% of government expenditure on education) of Spain in 2010?
Make the answer very short. 7.26. What is the difference between the Expenditure(% of government expenditure on education) in Ghana in 2009 and the Expenditure(% of government expenditure on education) in Hungary in 2010?
Your response must be concise. 15.29. What is the difference between the Expenditure(% of government expenditure on education) of Ghana in 2009 and the Expenditure(% of government expenditure on education) of Spain in 2010?
Make the answer very short. 7.59. What is the difference between the Expenditure(% of government expenditure on education) of Hungary in 2009 and the Expenditure(% of government expenditure on education) of Spain in 2010?
Give a very brief answer. -8.66. What is the average Expenditure(% of government expenditure on education) in Argentina per year?
Your answer should be compact. 35.04. What is the average Expenditure(% of government expenditure on education) in Ghana per year?
Ensure brevity in your answer.  36.3. What is the average Expenditure(% of government expenditure on education) in Hungary per year?
Make the answer very short. 18.54. What is the average Expenditure(% of government expenditure on education) in Spain per year?
Your response must be concise. 25.65. In the year 2001, what is the difference between the Expenditure(% of government expenditure on education) in Argentina and Expenditure(% of government expenditure on education) in Ghana?
Ensure brevity in your answer.  -3.62. In the year 2001, what is the difference between the Expenditure(% of government expenditure on education) in Argentina and Expenditure(% of government expenditure on education) in Hungary?
Offer a very short reply. 18.85. In the year 2001, what is the difference between the Expenditure(% of government expenditure on education) of Argentina and Expenditure(% of government expenditure on education) of Spain?
Offer a terse response. 11.83. In the year 2001, what is the difference between the Expenditure(% of government expenditure on education) of Ghana and Expenditure(% of government expenditure on education) of Hungary?
Offer a terse response. 22.46. In the year 2001, what is the difference between the Expenditure(% of government expenditure on education) of Ghana and Expenditure(% of government expenditure on education) of Spain?
Provide a short and direct response. 15.45. In the year 2001, what is the difference between the Expenditure(% of government expenditure on education) of Hungary and Expenditure(% of government expenditure on education) of Spain?
Make the answer very short. -7.02. In the year 2004, what is the difference between the Expenditure(% of government expenditure on education) of Argentina and Expenditure(% of government expenditure on education) of Ghana?
Offer a very short reply. -3.01. In the year 2004, what is the difference between the Expenditure(% of government expenditure on education) in Argentina and Expenditure(% of government expenditure on education) in Hungary?
Your response must be concise. 17.72. In the year 2004, what is the difference between the Expenditure(% of government expenditure on education) of Argentina and Expenditure(% of government expenditure on education) of Spain?
Your response must be concise. 10.71. In the year 2004, what is the difference between the Expenditure(% of government expenditure on education) in Ghana and Expenditure(% of government expenditure on education) in Hungary?
Ensure brevity in your answer.  20.73. In the year 2004, what is the difference between the Expenditure(% of government expenditure on education) in Ghana and Expenditure(% of government expenditure on education) in Spain?
Your answer should be very brief. 13.72. In the year 2004, what is the difference between the Expenditure(% of government expenditure on education) in Hungary and Expenditure(% of government expenditure on education) in Spain?
Provide a short and direct response. -7.01. In the year 2005, what is the difference between the Expenditure(% of government expenditure on education) of Argentina and Expenditure(% of government expenditure on education) of Ghana?
Your answer should be compact. -5.26. In the year 2005, what is the difference between the Expenditure(% of government expenditure on education) in Argentina and Expenditure(% of government expenditure on education) in Hungary?
Ensure brevity in your answer.  14.11. In the year 2005, what is the difference between the Expenditure(% of government expenditure on education) in Argentina and Expenditure(% of government expenditure on education) in Spain?
Give a very brief answer. 8.42. In the year 2005, what is the difference between the Expenditure(% of government expenditure on education) of Ghana and Expenditure(% of government expenditure on education) of Hungary?
Your answer should be very brief. 19.36. In the year 2005, what is the difference between the Expenditure(% of government expenditure on education) of Ghana and Expenditure(% of government expenditure on education) of Spain?
Provide a short and direct response. 13.68. In the year 2005, what is the difference between the Expenditure(% of government expenditure on education) in Hungary and Expenditure(% of government expenditure on education) in Spain?
Your response must be concise. -5.68. In the year 2006, what is the difference between the Expenditure(% of government expenditure on education) in Argentina and Expenditure(% of government expenditure on education) in Ghana?
Your answer should be very brief. -1.85. In the year 2006, what is the difference between the Expenditure(% of government expenditure on education) of Argentina and Expenditure(% of government expenditure on education) of Hungary?
Make the answer very short. 15.55. In the year 2006, what is the difference between the Expenditure(% of government expenditure on education) in Argentina and Expenditure(% of government expenditure on education) in Spain?
Offer a terse response. 9.34. In the year 2006, what is the difference between the Expenditure(% of government expenditure on education) in Ghana and Expenditure(% of government expenditure on education) in Hungary?
Your answer should be very brief. 17.4. In the year 2006, what is the difference between the Expenditure(% of government expenditure on education) of Ghana and Expenditure(% of government expenditure on education) of Spain?
Provide a short and direct response. 11.19. In the year 2006, what is the difference between the Expenditure(% of government expenditure on education) in Hungary and Expenditure(% of government expenditure on education) in Spain?
Offer a very short reply. -6.21. In the year 2007, what is the difference between the Expenditure(% of government expenditure on education) of Argentina and Expenditure(% of government expenditure on education) of Ghana?
Offer a very short reply. 1.25. In the year 2007, what is the difference between the Expenditure(% of government expenditure on education) in Argentina and Expenditure(% of government expenditure on education) in Hungary?
Provide a succinct answer. 16.42. In the year 2007, what is the difference between the Expenditure(% of government expenditure on education) of Argentina and Expenditure(% of government expenditure on education) of Spain?
Provide a short and direct response. 10.06. In the year 2007, what is the difference between the Expenditure(% of government expenditure on education) of Ghana and Expenditure(% of government expenditure on education) of Hungary?
Give a very brief answer. 15.17. In the year 2007, what is the difference between the Expenditure(% of government expenditure on education) in Ghana and Expenditure(% of government expenditure on education) in Spain?
Offer a terse response. 8.81. In the year 2007, what is the difference between the Expenditure(% of government expenditure on education) in Hungary and Expenditure(% of government expenditure on education) in Spain?
Make the answer very short. -6.36. In the year 2008, what is the difference between the Expenditure(% of government expenditure on education) in Argentina and Expenditure(% of government expenditure on education) in Ghana?
Your answer should be compact. 0.54. In the year 2008, what is the difference between the Expenditure(% of government expenditure on education) in Argentina and Expenditure(% of government expenditure on education) in Hungary?
Keep it short and to the point. 18.21. In the year 2008, what is the difference between the Expenditure(% of government expenditure on education) in Argentina and Expenditure(% of government expenditure on education) in Spain?
Your answer should be very brief. 9.73. In the year 2008, what is the difference between the Expenditure(% of government expenditure on education) in Ghana and Expenditure(% of government expenditure on education) in Hungary?
Your answer should be compact. 17.68. In the year 2008, what is the difference between the Expenditure(% of government expenditure on education) of Ghana and Expenditure(% of government expenditure on education) of Spain?
Offer a very short reply. 9.19. In the year 2008, what is the difference between the Expenditure(% of government expenditure on education) in Hungary and Expenditure(% of government expenditure on education) in Spain?
Provide a short and direct response. -8.49. In the year 2009, what is the difference between the Expenditure(% of government expenditure on education) of Argentina and Expenditure(% of government expenditure on education) of Ghana?
Your answer should be compact. -0.33. In the year 2009, what is the difference between the Expenditure(% of government expenditure on education) in Argentina and Expenditure(% of government expenditure on education) in Hungary?
Provide a succinct answer. 15.92. In the year 2009, what is the difference between the Expenditure(% of government expenditure on education) of Argentina and Expenditure(% of government expenditure on education) of Spain?
Offer a terse response. 7.5. In the year 2009, what is the difference between the Expenditure(% of government expenditure on education) in Ghana and Expenditure(% of government expenditure on education) in Hungary?
Your response must be concise. 16.25. In the year 2009, what is the difference between the Expenditure(% of government expenditure on education) in Ghana and Expenditure(% of government expenditure on education) in Spain?
Provide a short and direct response. 7.83. In the year 2009, what is the difference between the Expenditure(% of government expenditure on education) of Hungary and Expenditure(% of government expenditure on education) of Spain?
Make the answer very short. -8.42. In the year 2010, what is the difference between the Expenditure(% of government expenditure on education) of Argentina and Expenditure(% of government expenditure on education) of Ghana?
Offer a terse response. 2.19. In the year 2010, what is the difference between the Expenditure(% of government expenditure on education) of Argentina and Expenditure(% of government expenditure on education) of Hungary?
Your answer should be very brief. 15.21. In the year 2010, what is the difference between the Expenditure(% of government expenditure on education) in Argentina and Expenditure(% of government expenditure on education) in Spain?
Your answer should be compact. 7.51. In the year 2010, what is the difference between the Expenditure(% of government expenditure on education) in Ghana and Expenditure(% of government expenditure on education) in Hungary?
Provide a short and direct response. 13.02. In the year 2010, what is the difference between the Expenditure(% of government expenditure on education) of Ghana and Expenditure(% of government expenditure on education) of Spain?
Offer a terse response. 5.32. In the year 2010, what is the difference between the Expenditure(% of government expenditure on education) of Hungary and Expenditure(% of government expenditure on education) of Spain?
Provide a succinct answer. -7.7. What is the ratio of the Expenditure(% of government expenditure on education) of Ghana in 2001 to that in 2004?
Make the answer very short. 1.05. What is the ratio of the Expenditure(% of government expenditure on education) in Spain in 2001 to that in 2004?
Give a very brief answer. 1. What is the ratio of the Expenditure(% of government expenditure on education) in Argentina in 2001 to that in 2005?
Offer a very short reply. 1.11. What is the ratio of the Expenditure(% of government expenditure on education) in Ghana in 2001 to that in 2005?
Your response must be concise. 1.05. What is the ratio of the Expenditure(% of government expenditure on education) in Hungary in 2001 to that in 2005?
Offer a terse response. 0.95. What is the ratio of the Expenditure(% of government expenditure on education) in Spain in 2001 to that in 2005?
Offer a terse response. 1.01. What is the ratio of the Expenditure(% of government expenditure on education) in Argentina in 2001 to that in 2006?
Give a very brief answer. 1.08. What is the ratio of the Expenditure(% of government expenditure on education) in Ghana in 2001 to that in 2006?
Your answer should be compact. 1.13. What is the ratio of the Expenditure(% of government expenditure on education) in Hungary in 2001 to that in 2006?
Keep it short and to the point. 0.98. What is the ratio of the Expenditure(% of government expenditure on education) of Spain in 2001 to that in 2006?
Give a very brief answer. 1.01. What is the ratio of the Expenditure(% of government expenditure on education) of Argentina in 2001 to that in 2007?
Give a very brief answer. 1.07. What is the ratio of the Expenditure(% of government expenditure on education) in Ghana in 2001 to that in 2007?
Offer a very short reply. 1.21. What is the ratio of the Expenditure(% of government expenditure on education) in Spain in 2001 to that in 2007?
Give a very brief answer. 1.03. What is the ratio of the Expenditure(% of government expenditure on education) of Argentina in 2001 to that in 2008?
Ensure brevity in your answer.  1.08. What is the ratio of the Expenditure(% of government expenditure on education) of Ghana in 2001 to that in 2008?
Provide a short and direct response. 1.2. What is the ratio of the Expenditure(% of government expenditure on education) in Hungary in 2001 to that in 2008?
Give a very brief answer. 1.13. What is the ratio of the Expenditure(% of government expenditure on education) in Spain in 2001 to that in 2008?
Your answer should be compact. 1.03. What is the ratio of the Expenditure(% of government expenditure on education) in Argentina in 2001 to that in 2009?
Offer a very short reply. 1.16. What is the ratio of the Expenditure(% of government expenditure on education) of Ghana in 2001 to that in 2009?
Provide a short and direct response. 1.25. What is the ratio of the Expenditure(% of government expenditure on education) of Hungary in 2001 to that in 2009?
Offer a terse response. 1.13. What is the ratio of the Expenditure(% of government expenditure on education) in Spain in 2001 to that in 2009?
Make the answer very short. 1.03. What is the ratio of the Expenditure(% of government expenditure on education) of Argentina in 2001 to that in 2010?
Provide a succinct answer. 1.15. What is the ratio of the Expenditure(% of government expenditure on education) in Ghana in 2001 to that in 2010?
Offer a terse response. 1.35. What is the ratio of the Expenditure(% of government expenditure on education) of Hungary in 2001 to that in 2010?
Provide a succinct answer. 1.07. What is the ratio of the Expenditure(% of government expenditure on education) in Spain in 2001 to that in 2010?
Provide a succinct answer. 1.02. What is the ratio of the Expenditure(% of government expenditure on education) in Argentina in 2004 to that in 2005?
Provide a succinct answer. 1.07. What is the ratio of the Expenditure(% of government expenditure on education) of Ghana in 2004 to that in 2005?
Provide a succinct answer. 1.01. What is the ratio of the Expenditure(% of government expenditure on education) of Hungary in 2004 to that in 2005?
Provide a succinct answer. 0.94. What is the ratio of the Expenditure(% of government expenditure on education) of Spain in 2004 to that in 2005?
Your answer should be compact. 1.01. What is the ratio of the Expenditure(% of government expenditure on education) of Argentina in 2004 to that in 2006?
Offer a very short reply. 1.05. What is the ratio of the Expenditure(% of government expenditure on education) in Ghana in 2004 to that in 2006?
Keep it short and to the point. 1.08. What is the ratio of the Expenditure(% of government expenditure on education) in Hungary in 2004 to that in 2006?
Offer a terse response. 0.97. What is the ratio of the Expenditure(% of government expenditure on education) in Spain in 2004 to that in 2006?
Give a very brief answer. 1.01. What is the ratio of the Expenditure(% of government expenditure on education) of Argentina in 2004 to that in 2007?
Make the answer very short. 1.03. What is the ratio of the Expenditure(% of government expenditure on education) in Ghana in 2004 to that in 2007?
Ensure brevity in your answer.  1.16. What is the ratio of the Expenditure(% of government expenditure on education) in Spain in 2004 to that in 2007?
Your answer should be compact. 1.02. What is the ratio of the Expenditure(% of government expenditure on education) in Argentina in 2004 to that in 2008?
Keep it short and to the point. 1.05. What is the ratio of the Expenditure(% of government expenditure on education) of Ghana in 2004 to that in 2008?
Keep it short and to the point. 1.15. What is the ratio of the Expenditure(% of government expenditure on education) in Hungary in 2004 to that in 2008?
Provide a short and direct response. 1.12. What is the ratio of the Expenditure(% of government expenditure on education) in Spain in 2004 to that in 2008?
Keep it short and to the point. 1.02. What is the ratio of the Expenditure(% of government expenditure on education) in Argentina in 2004 to that in 2009?
Ensure brevity in your answer.  1.12. What is the ratio of the Expenditure(% of government expenditure on education) in Ghana in 2004 to that in 2009?
Offer a very short reply. 1.2. What is the ratio of the Expenditure(% of government expenditure on education) in Hungary in 2004 to that in 2009?
Ensure brevity in your answer.  1.12. What is the ratio of the Expenditure(% of government expenditure on education) in Spain in 2004 to that in 2009?
Ensure brevity in your answer.  1.03. What is the ratio of the Expenditure(% of government expenditure on education) in Argentina in 2004 to that in 2010?
Offer a terse response. 1.11. What is the ratio of the Expenditure(% of government expenditure on education) of Ghana in 2004 to that in 2010?
Provide a succinct answer. 1.29. What is the ratio of the Expenditure(% of government expenditure on education) in Hungary in 2004 to that in 2010?
Offer a very short reply. 1.06. What is the ratio of the Expenditure(% of government expenditure on education) in Spain in 2004 to that in 2010?
Make the answer very short. 1.02. What is the ratio of the Expenditure(% of government expenditure on education) of Argentina in 2005 to that in 2006?
Ensure brevity in your answer.  0.98. What is the ratio of the Expenditure(% of government expenditure on education) in Ghana in 2005 to that in 2006?
Your response must be concise. 1.07. What is the ratio of the Expenditure(% of government expenditure on education) of Hungary in 2005 to that in 2006?
Offer a very short reply. 1.03. What is the ratio of the Expenditure(% of government expenditure on education) in Argentina in 2005 to that in 2007?
Give a very brief answer. 0.96. What is the ratio of the Expenditure(% of government expenditure on education) of Ghana in 2005 to that in 2007?
Your answer should be very brief. 1.15. What is the ratio of the Expenditure(% of government expenditure on education) of Hungary in 2005 to that in 2007?
Give a very brief answer. 1.05. What is the ratio of the Expenditure(% of government expenditure on education) in Spain in 2005 to that in 2007?
Ensure brevity in your answer.  1.01. What is the ratio of the Expenditure(% of government expenditure on education) in Argentina in 2005 to that in 2008?
Your answer should be very brief. 0.97. What is the ratio of the Expenditure(% of government expenditure on education) of Ghana in 2005 to that in 2008?
Ensure brevity in your answer.  1.14. What is the ratio of the Expenditure(% of government expenditure on education) of Hungary in 2005 to that in 2008?
Your response must be concise. 1.19. What is the ratio of the Expenditure(% of government expenditure on education) in Spain in 2005 to that in 2008?
Give a very brief answer. 1.02. What is the ratio of the Expenditure(% of government expenditure on education) of Argentina in 2005 to that in 2009?
Give a very brief answer. 1.04. What is the ratio of the Expenditure(% of government expenditure on education) in Ghana in 2005 to that in 2009?
Give a very brief answer. 1.19. What is the ratio of the Expenditure(% of government expenditure on education) of Hungary in 2005 to that in 2009?
Provide a short and direct response. 1.19. What is the ratio of the Expenditure(% of government expenditure on education) of Spain in 2005 to that in 2009?
Your answer should be very brief. 1.02. What is the ratio of the Expenditure(% of government expenditure on education) of Argentina in 2005 to that in 2010?
Offer a terse response. 1.03. What is the ratio of the Expenditure(% of government expenditure on education) of Ghana in 2005 to that in 2010?
Provide a succinct answer. 1.28. What is the ratio of the Expenditure(% of government expenditure on education) in Hungary in 2005 to that in 2010?
Provide a succinct answer. 1.13. What is the ratio of the Expenditure(% of government expenditure on education) of Ghana in 2006 to that in 2007?
Your answer should be very brief. 1.08. What is the ratio of the Expenditure(% of government expenditure on education) in Hungary in 2006 to that in 2007?
Give a very brief answer. 1.02. What is the ratio of the Expenditure(% of government expenditure on education) of Spain in 2006 to that in 2007?
Offer a terse response. 1.01. What is the ratio of the Expenditure(% of government expenditure on education) of Argentina in 2006 to that in 2008?
Make the answer very short. 1. What is the ratio of the Expenditure(% of government expenditure on education) of Ghana in 2006 to that in 2008?
Provide a succinct answer. 1.07. What is the ratio of the Expenditure(% of government expenditure on education) of Hungary in 2006 to that in 2008?
Ensure brevity in your answer.  1.15. What is the ratio of the Expenditure(% of government expenditure on education) in Spain in 2006 to that in 2008?
Your answer should be very brief. 1.01. What is the ratio of the Expenditure(% of government expenditure on education) of Argentina in 2006 to that in 2009?
Your answer should be very brief. 1.07. What is the ratio of the Expenditure(% of government expenditure on education) of Ghana in 2006 to that in 2009?
Give a very brief answer. 1.11. What is the ratio of the Expenditure(% of government expenditure on education) of Hungary in 2006 to that in 2009?
Ensure brevity in your answer.  1.15. What is the ratio of the Expenditure(% of government expenditure on education) of Spain in 2006 to that in 2009?
Give a very brief answer. 1.02. What is the ratio of the Expenditure(% of government expenditure on education) of Argentina in 2006 to that in 2010?
Make the answer very short. 1.06. What is the ratio of the Expenditure(% of government expenditure on education) in Ghana in 2006 to that in 2010?
Keep it short and to the point. 1.2. What is the ratio of the Expenditure(% of government expenditure on education) of Hungary in 2006 to that in 2010?
Ensure brevity in your answer.  1.09. What is the ratio of the Expenditure(% of government expenditure on education) in Spain in 2006 to that in 2010?
Make the answer very short. 1.01. What is the ratio of the Expenditure(% of government expenditure on education) in Argentina in 2007 to that in 2008?
Provide a succinct answer. 1.01. What is the ratio of the Expenditure(% of government expenditure on education) in Hungary in 2007 to that in 2008?
Offer a very short reply. 1.13. What is the ratio of the Expenditure(% of government expenditure on education) in Argentina in 2007 to that in 2009?
Give a very brief answer. 1.08. What is the ratio of the Expenditure(% of government expenditure on education) in Ghana in 2007 to that in 2009?
Provide a short and direct response. 1.03. What is the ratio of the Expenditure(% of government expenditure on education) in Hungary in 2007 to that in 2009?
Provide a short and direct response. 1.13. What is the ratio of the Expenditure(% of government expenditure on education) of Argentina in 2007 to that in 2010?
Offer a terse response. 1.07. What is the ratio of the Expenditure(% of government expenditure on education) in Ghana in 2007 to that in 2010?
Offer a terse response. 1.11. What is the ratio of the Expenditure(% of government expenditure on education) of Hungary in 2007 to that in 2010?
Give a very brief answer. 1.07. What is the ratio of the Expenditure(% of government expenditure on education) of Spain in 2007 to that in 2010?
Provide a succinct answer. 0.99. What is the ratio of the Expenditure(% of government expenditure on education) in Argentina in 2008 to that in 2009?
Give a very brief answer. 1.07. What is the ratio of the Expenditure(% of government expenditure on education) in Ghana in 2008 to that in 2009?
Make the answer very short. 1.04. What is the ratio of the Expenditure(% of government expenditure on education) in Hungary in 2008 to that in 2009?
Give a very brief answer. 1. What is the ratio of the Expenditure(% of government expenditure on education) of Argentina in 2008 to that in 2010?
Give a very brief answer. 1.06. What is the ratio of the Expenditure(% of government expenditure on education) in Ghana in 2008 to that in 2010?
Ensure brevity in your answer.  1.12. What is the ratio of the Expenditure(% of government expenditure on education) in Hungary in 2008 to that in 2010?
Keep it short and to the point. 0.95. What is the ratio of the Expenditure(% of government expenditure on education) in Spain in 2008 to that in 2010?
Ensure brevity in your answer.  0.99. What is the ratio of the Expenditure(% of government expenditure on education) of Argentina in 2009 to that in 2010?
Offer a very short reply. 0.99. What is the ratio of the Expenditure(% of government expenditure on education) of Ghana in 2009 to that in 2010?
Offer a very short reply. 1.07. What is the ratio of the Expenditure(% of government expenditure on education) in Hungary in 2009 to that in 2010?
Provide a short and direct response. 0.95. What is the ratio of the Expenditure(% of government expenditure on education) of Spain in 2009 to that in 2010?
Your answer should be compact. 0.99. What is the difference between the highest and the second highest Expenditure(% of government expenditure on education) in Argentina?
Your response must be concise. 1.22. What is the difference between the highest and the second highest Expenditure(% of government expenditure on education) in Ghana?
Your answer should be very brief. 1.83. What is the difference between the highest and the second highest Expenditure(% of government expenditure on education) of Hungary?
Make the answer very short. 0.59. What is the difference between the highest and the second highest Expenditure(% of government expenditure on education) of Spain?
Your answer should be very brief. 0.11. What is the difference between the highest and the lowest Expenditure(% of government expenditure on education) in Argentina?
Provide a short and direct response. 5.12. What is the difference between the highest and the lowest Expenditure(% of government expenditure on education) of Ghana?
Keep it short and to the point. 10.67. What is the difference between the highest and the lowest Expenditure(% of government expenditure on education) in Hungary?
Offer a very short reply. 3.21. What is the difference between the highest and the lowest Expenditure(% of government expenditure on education) in Spain?
Give a very brief answer. 0.79. 